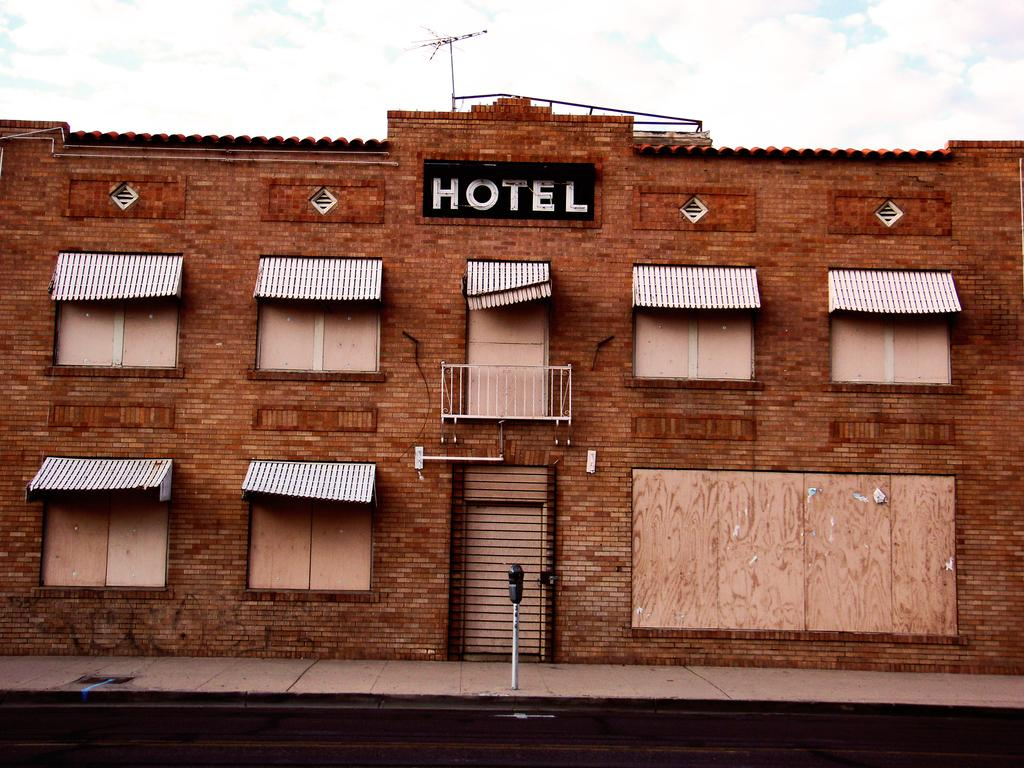What type of structure is visible in the image? There is a building in the image. What material is the building made of? The building is made of red bricks. What architectural features can be seen on the building? The building has windows and a network pole on top of it. What type of establishment might the building be associated with? The word "HOTEL" is written on the building, suggesting it is a hotel. Reasoning: Let' Let's think step by step in order to produce the conversation. We start by identifying the main subject in the image, which is the building. Then, we expand the conversation to include details about the building's construction, architectural features, and any text or signage present. Each question is designed to elicit a specific detail about the image that is known from the provided facts. Absurd Question/Answer: How many rings are visible on the building in the image? There are no rings visible on the building in the image. What type of cars are parked near the building in the image? There are no cars present in the image. Where is the sink located in the image? There is no sink present in the image. 